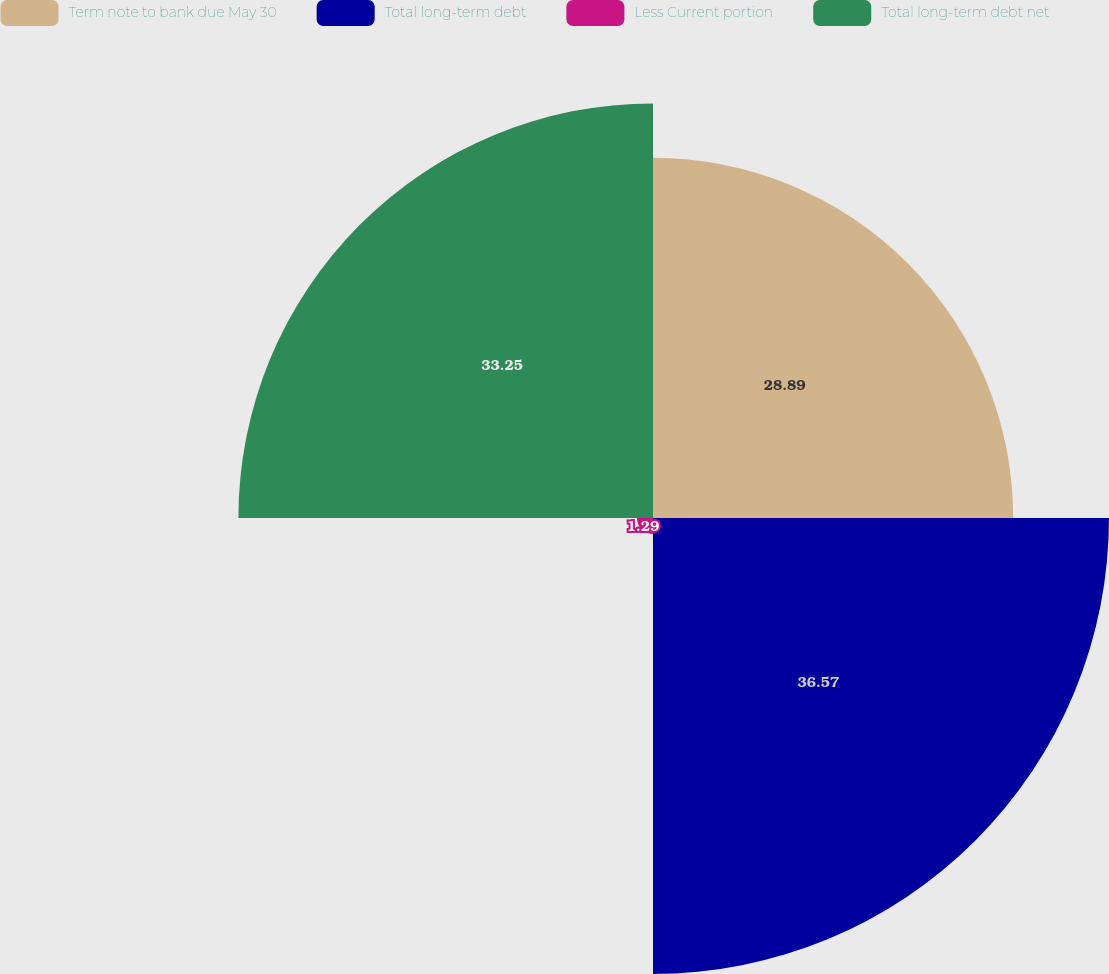Convert chart to OTSL. <chart><loc_0><loc_0><loc_500><loc_500><pie_chart><fcel>Term note to bank due May 30<fcel>Total long-term debt<fcel>Less Current portion<fcel>Total long-term debt net<nl><fcel>28.89%<fcel>36.57%<fcel>1.29%<fcel>33.25%<nl></chart> 